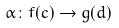<formula> <loc_0><loc_0><loc_500><loc_500>\alpha \colon f ( c ) \rightarrow g ( d )</formula> 